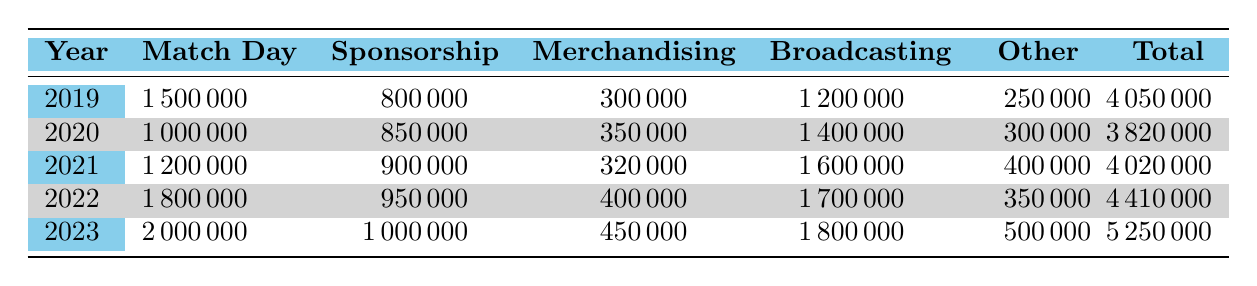What was the total revenue for ŠK Slovan Bratislava in 2021? From the table, the total revenue for the year 2021 is listed directly. It states that the total revenue is 4020000.
Answer: 4020000 What was the match day revenue in 2023? According to the table, the match day revenue for the year 2023 is explicitly provided, which is 2000000.
Answer: 2000000 Did the sponsorship revenue increase from 2019 to 2023? Checking the values from both years: in 2019 the sponsorship revenue was 800000, and in 2023 it was 1000000. The value increased, confirming the statement is true.
Answer: Yes What is the average merchandising revenue over the five years? To find the average, we sum the merchandising revenues from 2019 to 2023: (300000 + 350000 + 320000 + 400000 + 450000) = 1825000. Then divide by 5 (the number of years) to get 1825000 / 5 = 365000.
Answer: 365000 In which year was the broadcasting revenue highest, and what was that amount? By looking through the broadcasting revenue figures: in 2019 it was 1200000, in 2020 it was 1400000, in 2021 it was 1600000, in 2022 it was 1700000, and finally in 2023 it was 1800000. The highest revenue was in 2023 with 1800000.
Answer: 2023, 1800000 What is the percentage increase in total revenue from 2019 to 2023? To find the percentage increase, we first calculate the increase: 5250000 (2023) - 4050000 (2019) = 1200000. Next, we divide the increase by the original amount and multiply by 100: (1200000 / 4050000) * 100 = 29.63%.
Answer: 29.63% Did other income contribute less than 300000 in any year? Looking at the other income values: in 2019 it was 250000, in 2020 it was 300000, in 2021 it was 400000, in 2022 it was 350000, and in 2023 it was 500000. The only instance where it was less than 300000 was in 2019.
Answer: Yes What was the total match day revenue over the five years? By summing the match day revenues: (1500000 + 1000000 + 1200000 + 1800000 + 2000000) = 8500000. Therefore, the total match day revenue is 8500000.
Answer: 8500000 